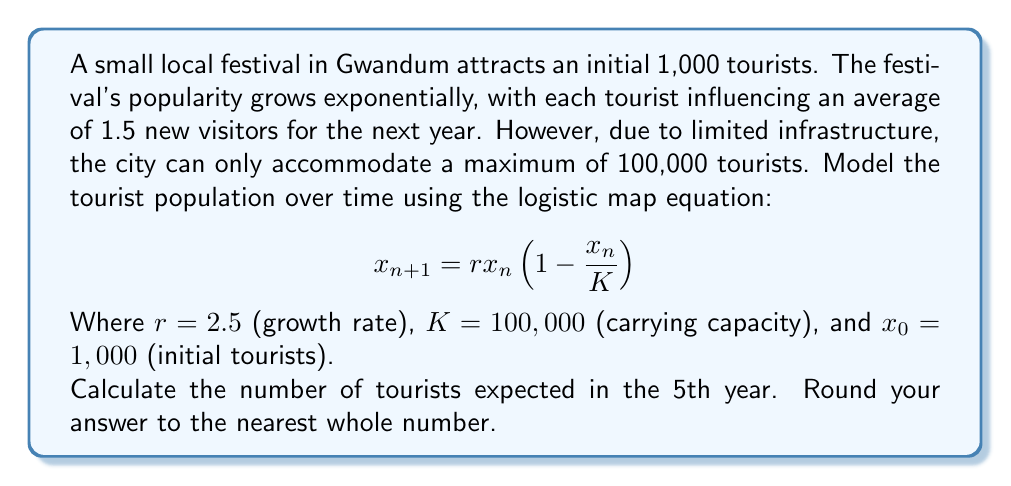Help me with this question. To solve this problem, we'll use the logistic map equation iteratively for 5 years:

1) Initial year (n = 0): $x_0 = 1,000$

2) Year 1 (n = 1):
   $$x_1 = 2.5 \cdot 1,000 \cdot (1 - \frac{1,000}{100,000}) = 2,475$$

3) Year 2 (n = 2):
   $$x_2 = 2.5 \cdot 2,475 \cdot (1 - \frac{2,475}{100,000}) = 6,045.47$$

4) Year 3 (n = 3):
   $$x_3 = 2.5 \cdot 6,045.47 \cdot (1 - \frac{6,045.47}{100,000}) = 14,208.76$$

5) Year 4 (n = 4):
   $$x_4 = 2.5 \cdot 14,208.76 \cdot (1 - \frac{14,208.76}{100,000}) = 30,471.39$$

6) Year 5 (n = 5):
   $$x_5 = 2.5 \cdot 30,471.39 \cdot (1 - \frac{30,471.39}{100,000}) = 52,956.36$$

Rounding to the nearest whole number, we get 52,956 tourists in the 5th year.
Answer: 52,956 